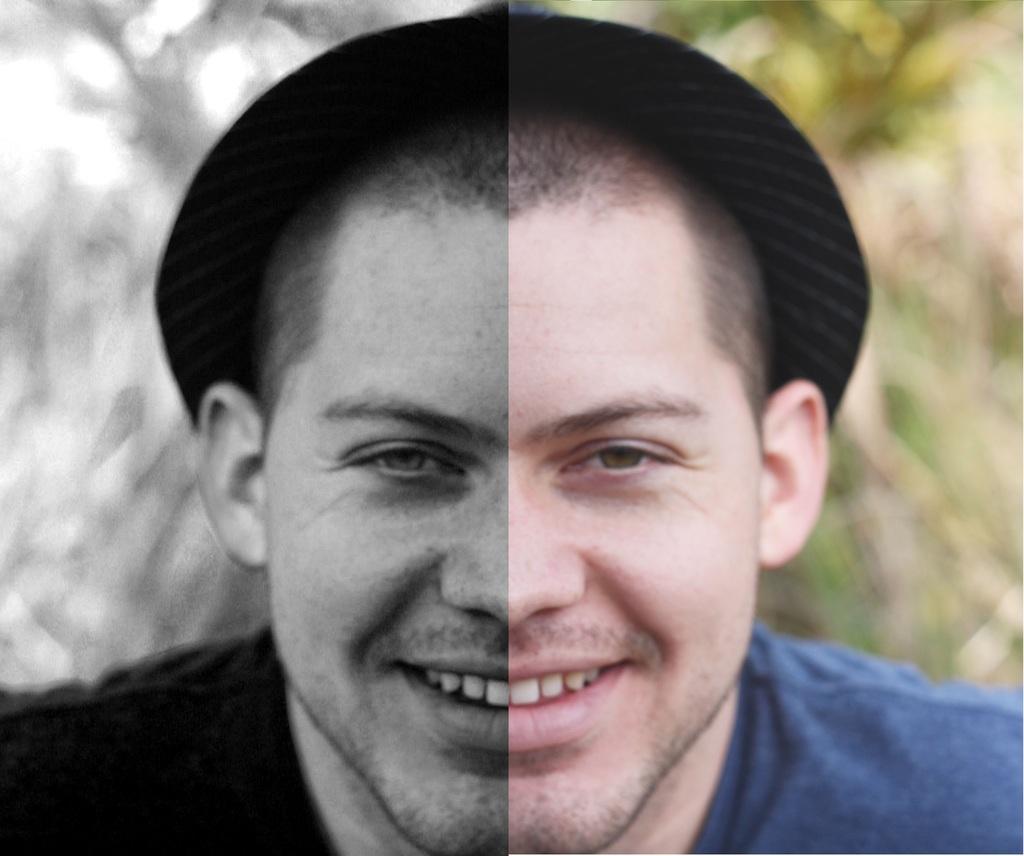Could you give a brief overview of what you see in this image? There is a man in the center of the image, he is wearing a hat, it seems to be an edited image and there is greenery in the background area. 